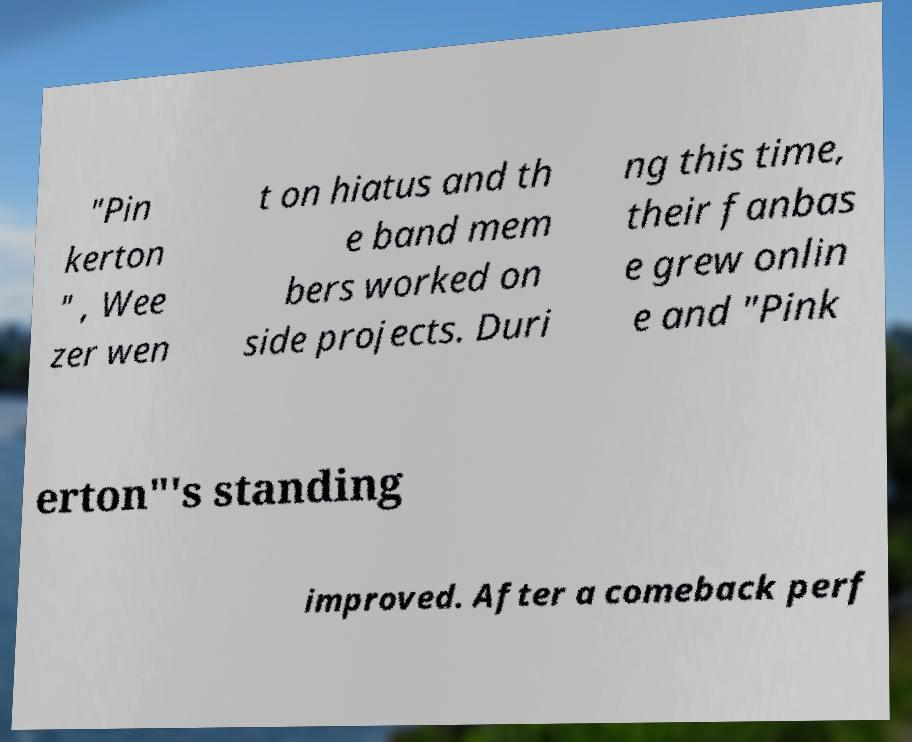Can you read and provide the text displayed in the image?This photo seems to have some interesting text. Can you extract and type it out for me? "Pin kerton " , Wee zer wen t on hiatus and th e band mem bers worked on side projects. Duri ng this time, their fanbas e grew onlin e and "Pink erton"'s standing improved. After a comeback perf 